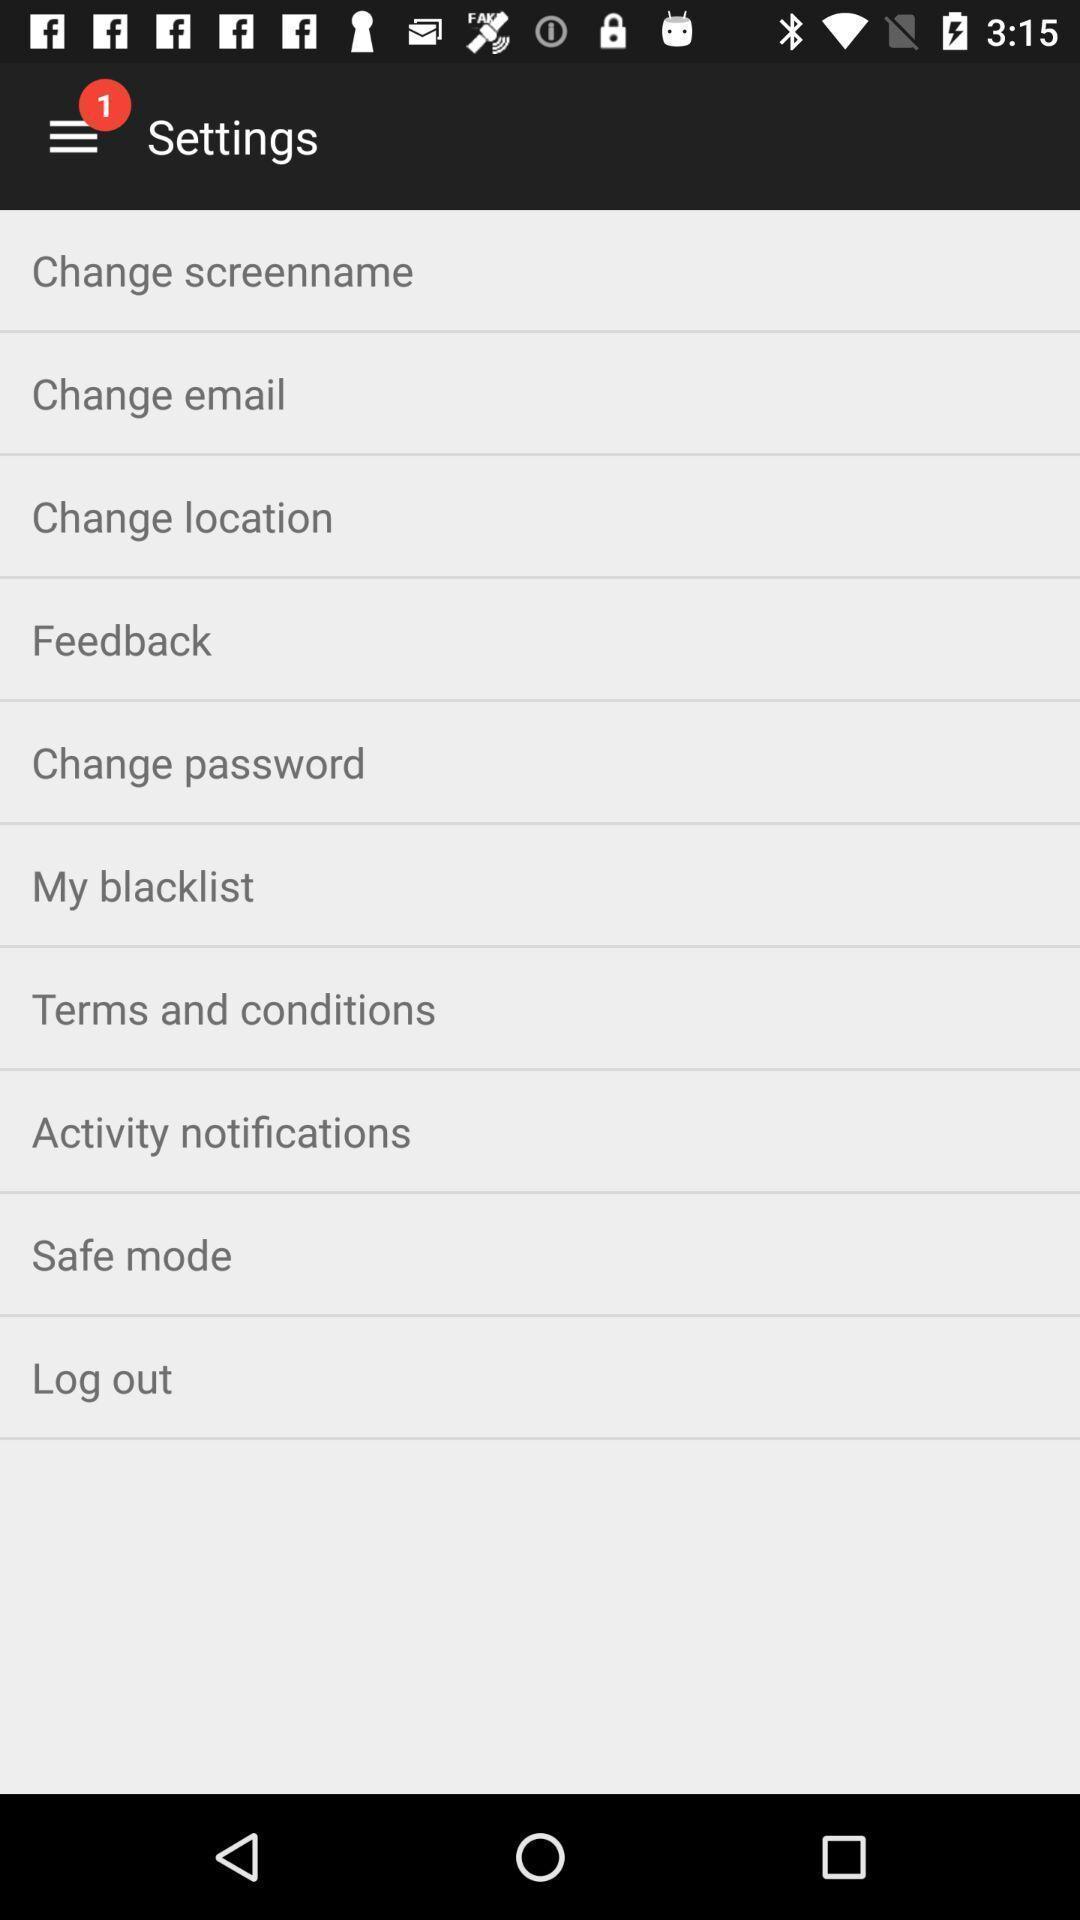Describe the key features of this screenshot. Settings page. 